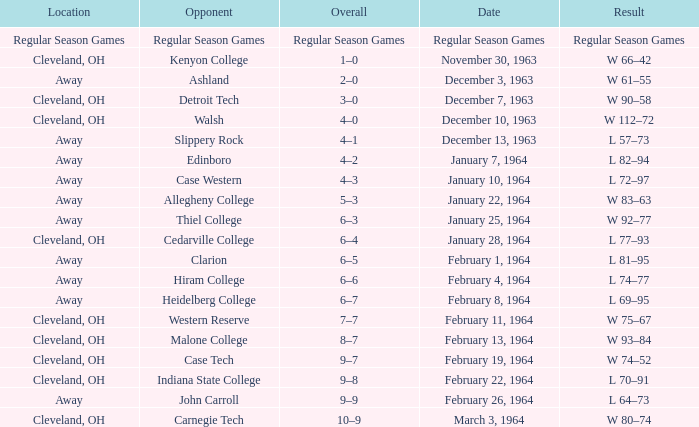What is the Overall with a Date that is february 4, 1964? 6–6. 